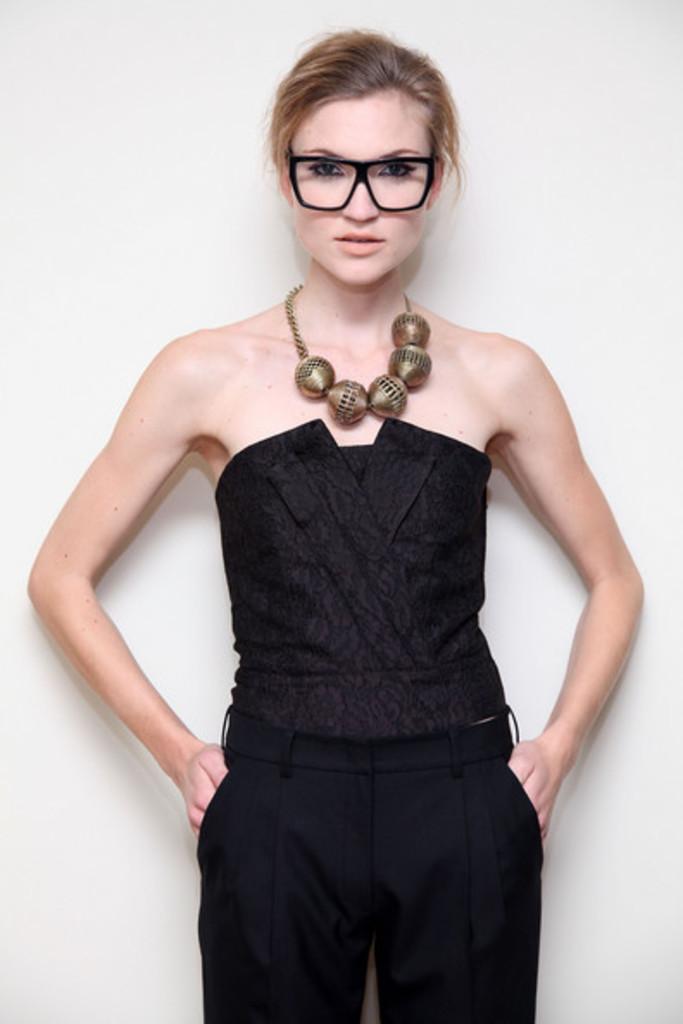In one or two sentences, can you explain what this image depicts? In this image I can see a woman standing, wearing a black dress and a necklace. There is a white background. 